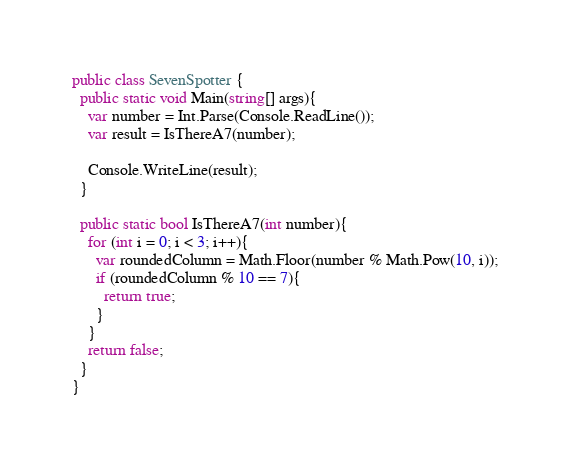Convert code to text. <code><loc_0><loc_0><loc_500><loc_500><_C#_>public class SevenSpotter {
  public static void Main(string[] args){
    var number = Int.Parse(Console.ReadLine());
    var result = IsThereA7(number);
    
    Console.WriteLine(result);
  }
  
  public static bool IsThereA7(int number){
    for (int i = 0; i < 3; i++){
      var roundedColumn = Math.Floor(number % Math.Pow(10, i));
      if (roundedColumn % 10 == 7){
        return true;
      }
    }
    return false;
  }
}
</code> 